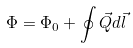Convert formula to latex. <formula><loc_0><loc_0><loc_500><loc_500>\Phi = \Phi _ { 0 } + \oint { \vec { Q } } d { \vec { l } }</formula> 